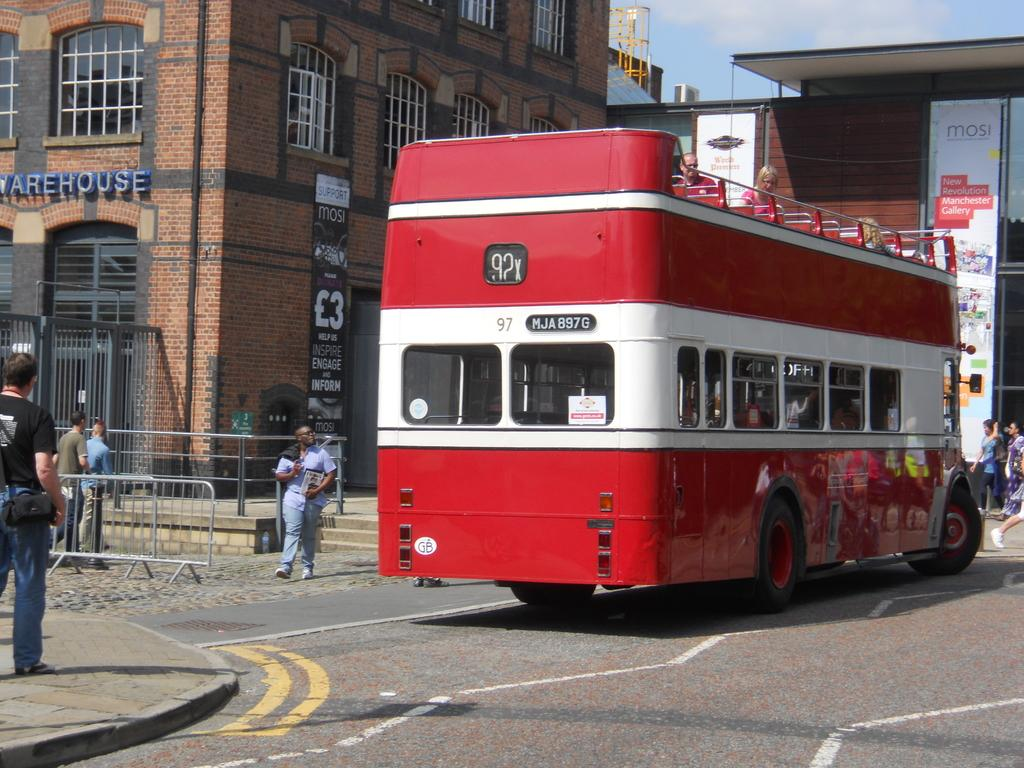<image>
Share a concise interpretation of the image provided. A city street with a red bus on the street while people walking by a building called Warehouse on the front. 